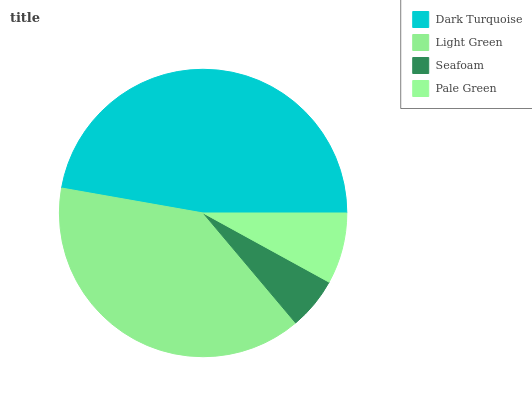Is Seafoam the minimum?
Answer yes or no. Yes. Is Dark Turquoise the maximum?
Answer yes or no. Yes. Is Light Green the minimum?
Answer yes or no. No. Is Light Green the maximum?
Answer yes or no. No. Is Dark Turquoise greater than Light Green?
Answer yes or no. Yes. Is Light Green less than Dark Turquoise?
Answer yes or no. Yes. Is Light Green greater than Dark Turquoise?
Answer yes or no. No. Is Dark Turquoise less than Light Green?
Answer yes or no. No. Is Light Green the high median?
Answer yes or no. Yes. Is Pale Green the low median?
Answer yes or no. Yes. Is Seafoam the high median?
Answer yes or no. No. Is Light Green the low median?
Answer yes or no. No. 